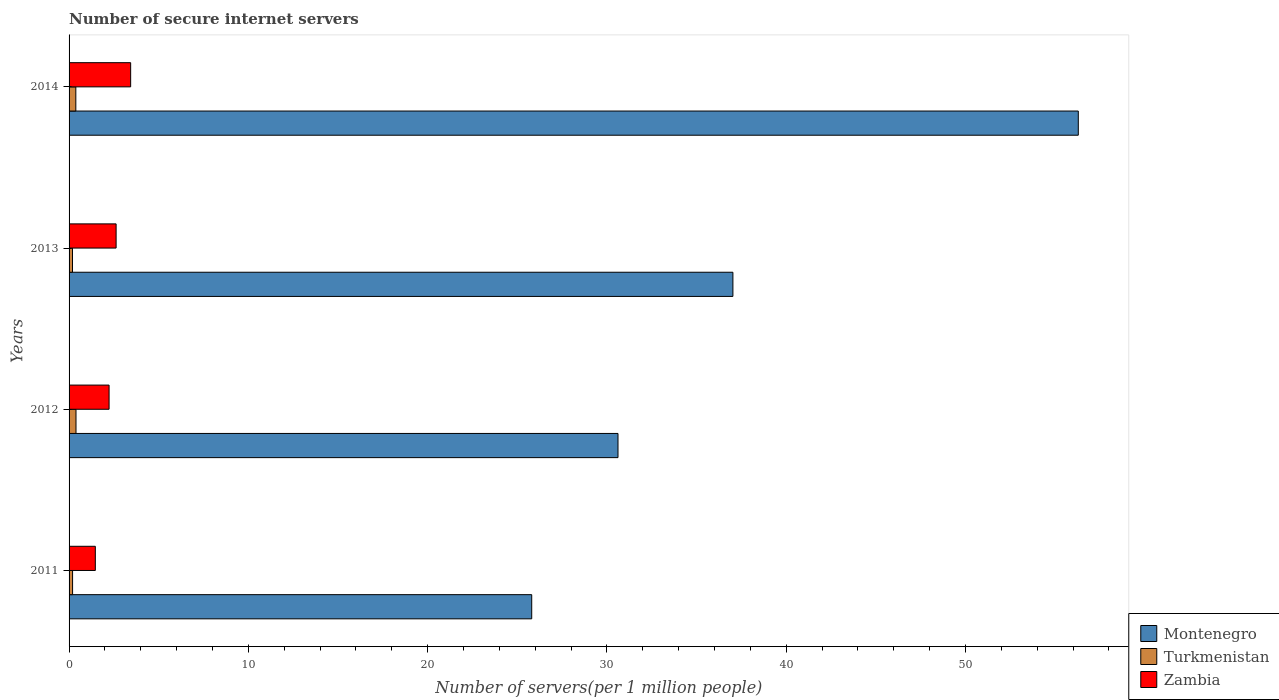How many different coloured bars are there?
Your answer should be compact. 3. How many groups of bars are there?
Keep it short and to the point. 4. Are the number of bars on each tick of the Y-axis equal?
Offer a very short reply. Yes. How many bars are there on the 1st tick from the top?
Make the answer very short. 3. What is the number of secure internet servers in Zambia in 2011?
Make the answer very short. 1.46. Across all years, what is the maximum number of secure internet servers in Turkmenistan?
Your answer should be compact. 0.39. Across all years, what is the minimum number of secure internet servers in Zambia?
Provide a short and direct response. 1.46. What is the total number of secure internet servers in Turkmenistan in the graph?
Your answer should be very brief. 1.15. What is the difference between the number of secure internet servers in Montenegro in 2012 and that in 2014?
Offer a terse response. -25.67. What is the difference between the number of secure internet servers in Turkmenistan in 2011 and the number of secure internet servers in Montenegro in 2012?
Provide a succinct answer. -30.42. What is the average number of secure internet servers in Zambia per year?
Offer a terse response. 2.44. In the year 2011, what is the difference between the number of secure internet servers in Zambia and number of secure internet servers in Turkmenistan?
Your response must be concise. 1.27. In how many years, is the number of secure internet servers in Montenegro greater than 54 ?
Your response must be concise. 1. What is the ratio of the number of secure internet servers in Turkmenistan in 2011 to that in 2013?
Offer a terse response. 1.03. Is the difference between the number of secure internet servers in Zambia in 2011 and 2012 greater than the difference between the number of secure internet servers in Turkmenistan in 2011 and 2012?
Your response must be concise. No. What is the difference between the highest and the second highest number of secure internet servers in Montenegro?
Provide a short and direct response. 19.26. What is the difference between the highest and the lowest number of secure internet servers in Turkmenistan?
Provide a short and direct response. 0.2. In how many years, is the number of secure internet servers in Montenegro greater than the average number of secure internet servers in Montenegro taken over all years?
Your response must be concise. 1. Is the sum of the number of secure internet servers in Turkmenistan in 2011 and 2013 greater than the maximum number of secure internet servers in Zambia across all years?
Provide a succinct answer. No. What does the 1st bar from the top in 2014 represents?
Your answer should be very brief. Zambia. What does the 3rd bar from the bottom in 2013 represents?
Provide a succinct answer. Zambia. How many bars are there?
Provide a short and direct response. 12. Are all the bars in the graph horizontal?
Provide a short and direct response. Yes. How many years are there in the graph?
Make the answer very short. 4. Does the graph contain any zero values?
Your answer should be compact. No. Does the graph contain grids?
Give a very brief answer. No. Where does the legend appear in the graph?
Give a very brief answer. Bottom right. What is the title of the graph?
Provide a succinct answer. Number of secure internet servers. What is the label or title of the X-axis?
Make the answer very short. Number of servers(per 1 million people). What is the label or title of the Y-axis?
Your answer should be compact. Years. What is the Number of servers(per 1 million people) in Montenegro in 2011?
Your answer should be very brief. 25.8. What is the Number of servers(per 1 million people) of Turkmenistan in 2011?
Keep it short and to the point. 0.2. What is the Number of servers(per 1 million people) of Zambia in 2011?
Your answer should be compact. 1.46. What is the Number of servers(per 1 million people) of Montenegro in 2012?
Make the answer very short. 30.62. What is the Number of servers(per 1 million people) in Turkmenistan in 2012?
Your answer should be very brief. 0.39. What is the Number of servers(per 1 million people) of Zambia in 2012?
Offer a very short reply. 2.23. What is the Number of servers(per 1 million people) in Montenegro in 2013?
Provide a succinct answer. 37.02. What is the Number of servers(per 1 million people) in Turkmenistan in 2013?
Keep it short and to the point. 0.19. What is the Number of servers(per 1 million people) of Zambia in 2013?
Give a very brief answer. 2.62. What is the Number of servers(per 1 million people) in Montenegro in 2014?
Offer a terse response. 56.29. What is the Number of servers(per 1 million people) in Turkmenistan in 2014?
Your response must be concise. 0.38. What is the Number of servers(per 1 million people) in Zambia in 2014?
Your answer should be very brief. 3.43. Across all years, what is the maximum Number of servers(per 1 million people) in Montenegro?
Your answer should be compact. 56.29. Across all years, what is the maximum Number of servers(per 1 million people) of Turkmenistan?
Give a very brief answer. 0.39. Across all years, what is the maximum Number of servers(per 1 million people) of Zambia?
Provide a succinct answer. 3.43. Across all years, what is the minimum Number of servers(per 1 million people) in Montenegro?
Ensure brevity in your answer.  25.8. Across all years, what is the minimum Number of servers(per 1 million people) in Turkmenistan?
Your answer should be very brief. 0.19. Across all years, what is the minimum Number of servers(per 1 million people) of Zambia?
Your answer should be very brief. 1.46. What is the total Number of servers(per 1 million people) of Montenegro in the graph?
Offer a very short reply. 149.73. What is the total Number of servers(per 1 million people) of Turkmenistan in the graph?
Your answer should be very brief. 1.15. What is the total Number of servers(per 1 million people) of Zambia in the graph?
Keep it short and to the point. 9.75. What is the difference between the Number of servers(per 1 million people) of Montenegro in 2011 and that in 2012?
Offer a terse response. -4.81. What is the difference between the Number of servers(per 1 million people) of Turkmenistan in 2011 and that in 2012?
Your answer should be compact. -0.19. What is the difference between the Number of servers(per 1 million people) of Zambia in 2011 and that in 2012?
Provide a succinct answer. -0.77. What is the difference between the Number of servers(per 1 million people) of Montenegro in 2011 and that in 2013?
Provide a succinct answer. -11.22. What is the difference between the Number of servers(per 1 million people) of Turkmenistan in 2011 and that in 2013?
Make the answer very short. 0.01. What is the difference between the Number of servers(per 1 million people) of Zambia in 2011 and that in 2013?
Make the answer very short. -1.16. What is the difference between the Number of servers(per 1 million people) in Montenegro in 2011 and that in 2014?
Your response must be concise. -30.48. What is the difference between the Number of servers(per 1 million people) in Turkmenistan in 2011 and that in 2014?
Give a very brief answer. -0.18. What is the difference between the Number of servers(per 1 million people) in Zambia in 2011 and that in 2014?
Your answer should be compact. -1.97. What is the difference between the Number of servers(per 1 million people) in Montenegro in 2012 and that in 2013?
Provide a succinct answer. -6.41. What is the difference between the Number of servers(per 1 million people) of Turkmenistan in 2012 and that in 2013?
Give a very brief answer. 0.2. What is the difference between the Number of servers(per 1 million people) in Zambia in 2012 and that in 2013?
Keep it short and to the point. -0.39. What is the difference between the Number of servers(per 1 million people) in Montenegro in 2012 and that in 2014?
Keep it short and to the point. -25.67. What is the difference between the Number of servers(per 1 million people) in Turkmenistan in 2012 and that in 2014?
Ensure brevity in your answer.  0.01. What is the difference between the Number of servers(per 1 million people) in Zambia in 2012 and that in 2014?
Keep it short and to the point. -1.2. What is the difference between the Number of servers(per 1 million people) of Montenegro in 2013 and that in 2014?
Your response must be concise. -19.26. What is the difference between the Number of servers(per 1 million people) of Turkmenistan in 2013 and that in 2014?
Offer a very short reply. -0.19. What is the difference between the Number of servers(per 1 million people) of Zambia in 2013 and that in 2014?
Make the answer very short. -0.81. What is the difference between the Number of servers(per 1 million people) of Montenegro in 2011 and the Number of servers(per 1 million people) of Turkmenistan in 2012?
Your answer should be very brief. 25.42. What is the difference between the Number of servers(per 1 million people) in Montenegro in 2011 and the Number of servers(per 1 million people) in Zambia in 2012?
Keep it short and to the point. 23.57. What is the difference between the Number of servers(per 1 million people) in Turkmenistan in 2011 and the Number of servers(per 1 million people) in Zambia in 2012?
Your answer should be very brief. -2.04. What is the difference between the Number of servers(per 1 million people) in Montenegro in 2011 and the Number of servers(per 1 million people) in Turkmenistan in 2013?
Keep it short and to the point. 25.61. What is the difference between the Number of servers(per 1 million people) in Montenegro in 2011 and the Number of servers(per 1 million people) in Zambia in 2013?
Ensure brevity in your answer.  23.18. What is the difference between the Number of servers(per 1 million people) of Turkmenistan in 2011 and the Number of servers(per 1 million people) of Zambia in 2013?
Your answer should be compact. -2.43. What is the difference between the Number of servers(per 1 million people) in Montenegro in 2011 and the Number of servers(per 1 million people) in Turkmenistan in 2014?
Provide a succinct answer. 25.43. What is the difference between the Number of servers(per 1 million people) in Montenegro in 2011 and the Number of servers(per 1 million people) in Zambia in 2014?
Ensure brevity in your answer.  22.37. What is the difference between the Number of servers(per 1 million people) in Turkmenistan in 2011 and the Number of servers(per 1 million people) in Zambia in 2014?
Make the answer very short. -3.24. What is the difference between the Number of servers(per 1 million people) of Montenegro in 2012 and the Number of servers(per 1 million people) of Turkmenistan in 2013?
Offer a terse response. 30.42. What is the difference between the Number of servers(per 1 million people) of Montenegro in 2012 and the Number of servers(per 1 million people) of Zambia in 2013?
Your response must be concise. 27.99. What is the difference between the Number of servers(per 1 million people) in Turkmenistan in 2012 and the Number of servers(per 1 million people) in Zambia in 2013?
Your response must be concise. -2.24. What is the difference between the Number of servers(per 1 million people) of Montenegro in 2012 and the Number of servers(per 1 million people) of Turkmenistan in 2014?
Keep it short and to the point. 30.24. What is the difference between the Number of servers(per 1 million people) of Montenegro in 2012 and the Number of servers(per 1 million people) of Zambia in 2014?
Provide a short and direct response. 27.18. What is the difference between the Number of servers(per 1 million people) of Turkmenistan in 2012 and the Number of servers(per 1 million people) of Zambia in 2014?
Your answer should be compact. -3.05. What is the difference between the Number of servers(per 1 million people) of Montenegro in 2013 and the Number of servers(per 1 million people) of Turkmenistan in 2014?
Ensure brevity in your answer.  36.65. What is the difference between the Number of servers(per 1 million people) of Montenegro in 2013 and the Number of servers(per 1 million people) of Zambia in 2014?
Keep it short and to the point. 33.59. What is the difference between the Number of servers(per 1 million people) of Turkmenistan in 2013 and the Number of servers(per 1 million people) of Zambia in 2014?
Your answer should be very brief. -3.24. What is the average Number of servers(per 1 million people) of Montenegro per year?
Keep it short and to the point. 37.43. What is the average Number of servers(per 1 million people) in Turkmenistan per year?
Ensure brevity in your answer.  0.29. What is the average Number of servers(per 1 million people) of Zambia per year?
Offer a very short reply. 2.44. In the year 2011, what is the difference between the Number of servers(per 1 million people) of Montenegro and Number of servers(per 1 million people) of Turkmenistan?
Make the answer very short. 25.61. In the year 2011, what is the difference between the Number of servers(per 1 million people) of Montenegro and Number of servers(per 1 million people) of Zambia?
Ensure brevity in your answer.  24.34. In the year 2011, what is the difference between the Number of servers(per 1 million people) of Turkmenistan and Number of servers(per 1 million people) of Zambia?
Make the answer very short. -1.27. In the year 2012, what is the difference between the Number of servers(per 1 million people) in Montenegro and Number of servers(per 1 million people) in Turkmenistan?
Offer a terse response. 30.23. In the year 2012, what is the difference between the Number of servers(per 1 million people) of Montenegro and Number of servers(per 1 million people) of Zambia?
Your response must be concise. 28.38. In the year 2012, what is the difference between the Number of servers(per 1 million people) of Turkmenistan and Number of servers(per 1 million people) of Zambia?
Make the answer very short. -1.85. In the year 2013, what is the difference between the Number of servers(per 1 million people) of Montenegro and Number of servers(per 1 million people) of Turkmenistan?
Provide a succinct answer. 36.83. In the year 2013, what is the difference between the Number of servers(per 1 million people) of Montenegro and Number of servers(per 1 million people) of Zambia?
Your answer should be very brief. 34.4. In the year 2013, what is the difference between the Number of servers(per 1 million people) in Turkmenistan and Number of servers(per 1 million people) in Zambia?
Your answer should be very brief. -2.43. In the year 2014, what is the difference between the Number of servers(per 1 million people) in Montenegro and Number of servers(per 1 million people) in Turkmenistan?
Give a very brief answer. 55.91. In the year 2014, what is the difference between the Number of servers(per 1 million people) of Montenegro and Number of servers(per 1 million people) of Zambia?
Provide a succinct answer. 52.85. In the year 2014, what is the difference between the Number of servers(per 1 million people) in Turkmenistan and Number of servers(per 1 million people) in Zambia?
Make the answer very short. -3.06. What is the ratio of the Number of servers(per 1 million people) in Montenegro in 2011 to that in 2012?
Make the answer very short. 0.84. What is the ratio of the Number of servers(per 1 million people) in Turkmenistan in 2011 to that in 2012?
Keep it short and to the point. 0.51. What is the ratio of the Number of servers(per 1 million people) in Zambia in 2011 to that in 2012?
Give a very brief answer. 0.66. What is the ratio of the Number of servers(per 1 million people) in Montenegro in 2011 to that in 2013?
Your answer should be compact. 0.7. What is the ratio of the Number of servers(per 1 million people) in Turkmenistan in 2011 to that in 2013?
Provide a succinct answer. 1.03. What is the ratio of the Number of servers(per 1 million people) of Zambia in 2011 to that in 2013?
Ensure brevity in your answer.  0.56. What is the ratio of the Number of servers(per 1 million people) of Montenegro in 2011 to that in 2014?
Ensure brevity in your answer.  0.46. What is the ratio of the Number of servers(per 1 million people) of Turkmenistan in 2011 to that in 2014?
Give a very brief answer. 0.52. What is the ratio of the Number of servers(per 1 million people) in Zambia in 2011 to that in 2014?
Your answer should be compact. 0.43. What is the ratio of the Number of servers(per 1 million people) in Montenegro in 2012 to that in 2013?
Provide a succinct answer. 0.83. What is the ratio of the Number of servers(per 1 million people) of Turkmenistan in 2012 to that in 2013?
Your response must be concise. 2.03. What is the ratio of the Number of servers(per 1 million people) of Zambia in 2012 to that in 2013?
Your answer should be very brief. 0.85. What is the ratio of the Number of servers(per 1 million people) of Montenegro in 2012 to that in 2014?
Give a very brief answer. 0.54. What is the ratio of the Number of servers(per 1 million people) in Zambia in 2012 to that in 2014?
Make the answer very short. 0.65. What is the ratio of the Number of servers(per 1 million people) of Montenegro in 2013 to that in 2014?
Make the answer very short. 0.66. What is the ratio of the Number of servers(per 1 million people) of Turkmenistan in 2013 to that in 2014?
Ensure brevity in your answer.  0.51. What is the ratio of the Number of servers(per 1 million people) in Zambia in 2013 to that in 2014?
Give a very brief answer. 0.76. What is the difference between the highest and the second highest Number of servers(per 1 million people) in Montenegro?
Your response must be concise. 19.26. What is the difference between the highest and the second highest Number of servers(per 1 million people) in Turkmenistan?
Make the answer very short. 0.01. What is the difference between the highest and the second highest Number of servers(per 1 million people) of Zambia?
Your answer should be compact. 0.81. What is the difference between the highest and the lowest Number of servers(per 1 million people) in Montenegro?
Keep it short and to the point. 30.48. What is the difference between the highest and the lowest Number of servers(per 1 million people) of Turkmenistan?
Provide a succinct answer. 0.2. What is the difference between the highest and the lowest Number of servers(per 1 million people) of Zambia?
Ensure brevity in your answer.  1.97. 